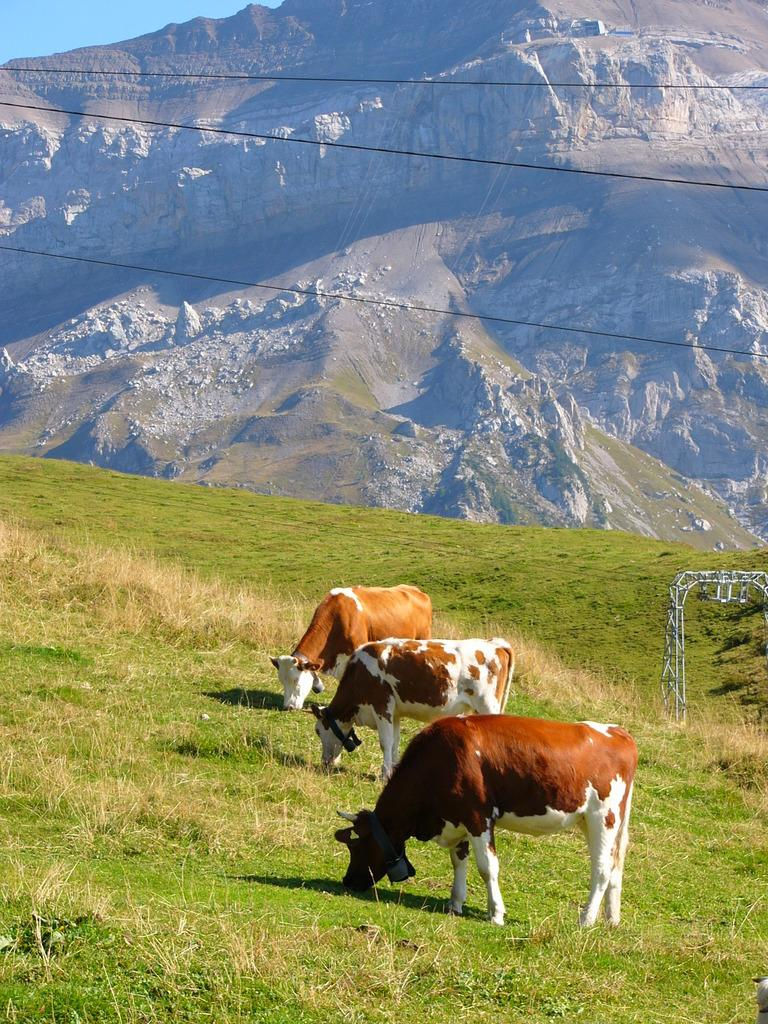How many cows can be seen in the image? There are three cows in the image. What are the cows doing in the image? The cows are eating grass in the image. What can be seen in the background of the image? There are hills in the background of the image. What is present on the hills? There are stones on the hills. What is visible at the top of the image? There are wires visible at the top of the image. What type of doll is sitting at the dinner table in the image? There is no doll or dinner table present in the image; it features three cows eating grass with hills, stones, and wires in the background. What type of airport can be seen in the image? There is no airport present in the image; it features three cows eating grass with hills, stones, and wires in the background. 